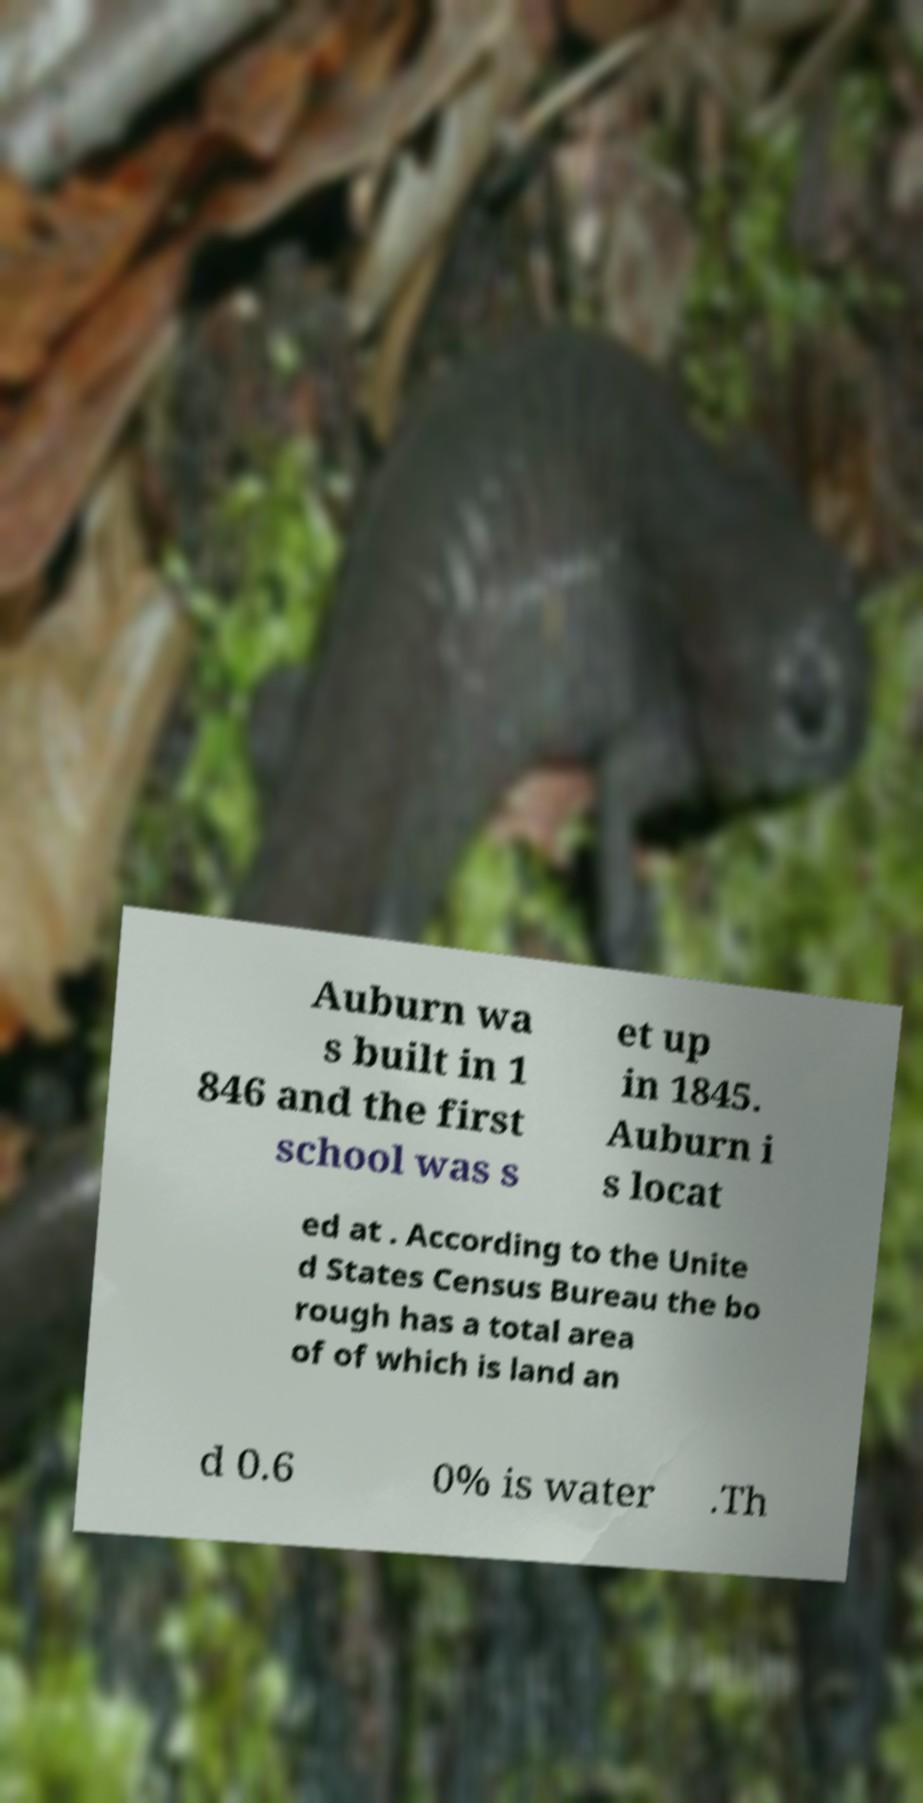Please identify and transcribe the text found in this image. Auburn wa s built in 1 846 and the first school was s et up in 1845. Auburn i s locat ed at . According to the Unite d States Census Bureau the bo rough has a total area of of which is land an d 0.6 0% is water .Th 